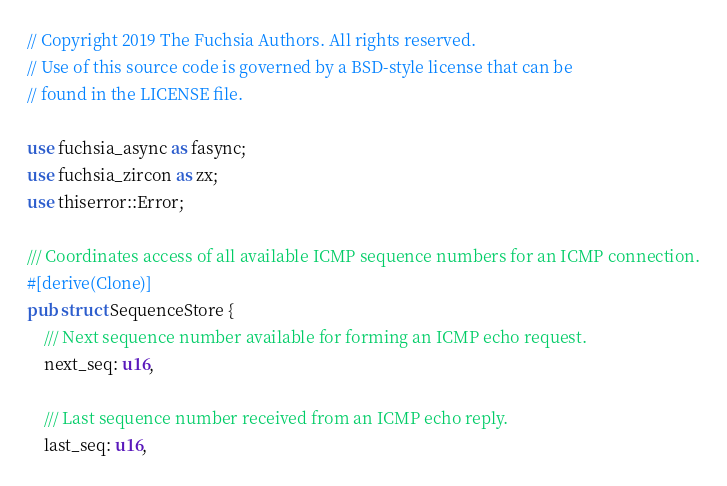<code> <loc_0><loc_0><loc_500><loc_500><_Rust_>// Copyright 2019 The Fuchsia Authors. All rights reserved.
// Use of this source code is governed by a BSD-style license that can be
// found in the LICENSE file.

use fuchsia_async as fasync;
use fuchsia_zircon as zx;
use thiserror::Error;

/// Coordinates access of all available ICMP sequence numbers for an ICMP connection.
#[derive(Clone)]
pub struct SequenceStore {
    /// Next sequence number available for forming an ICMP echo request.
    next_seq: u16,

    /// Last sequence number received from an ICMP echo reply.
    last_seq: u16,
</code> 